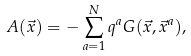<formula> <loc_0><loc_0><loc_500><loc_500>A ( \vec { x } ) = - \sum _ { a = 1 } ^ { N } q ^ { a } G ( \vec { x } , \vec { x } ^ { a } ) ,</formula> 